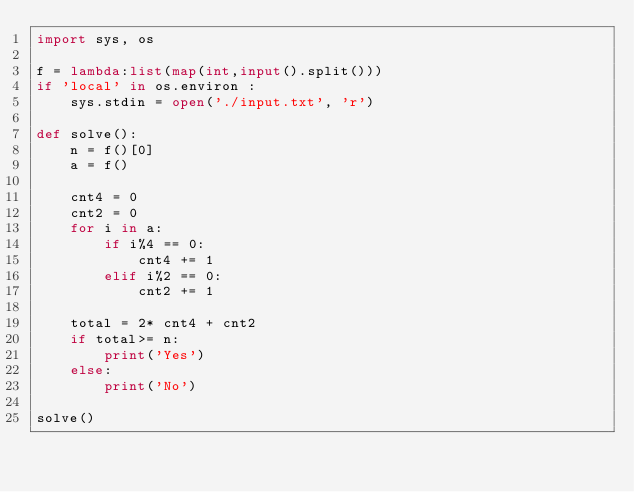Convert code to text. <code><loc_0><loc_0><loc_500><loc_500><_Python_>import sys, os

f = lambda:list(map(int,input().split()))
if 'local' in os.environ :
    sys.stdin = open('./input.txt', 'r')

def solve():
    n = f()[0]
    a = f()

    cnt4 = 0
    cnt2 = 0
    for i in a:
        if i%4 == 0:
            cnt4 += 1
        elif i%2 == 0:
            cnt2 += 1
    
    total = 2* cnt4 + cnt2
    if total>= n:
        print('Yes')
    else:
        print('No')

solve()
</code> 